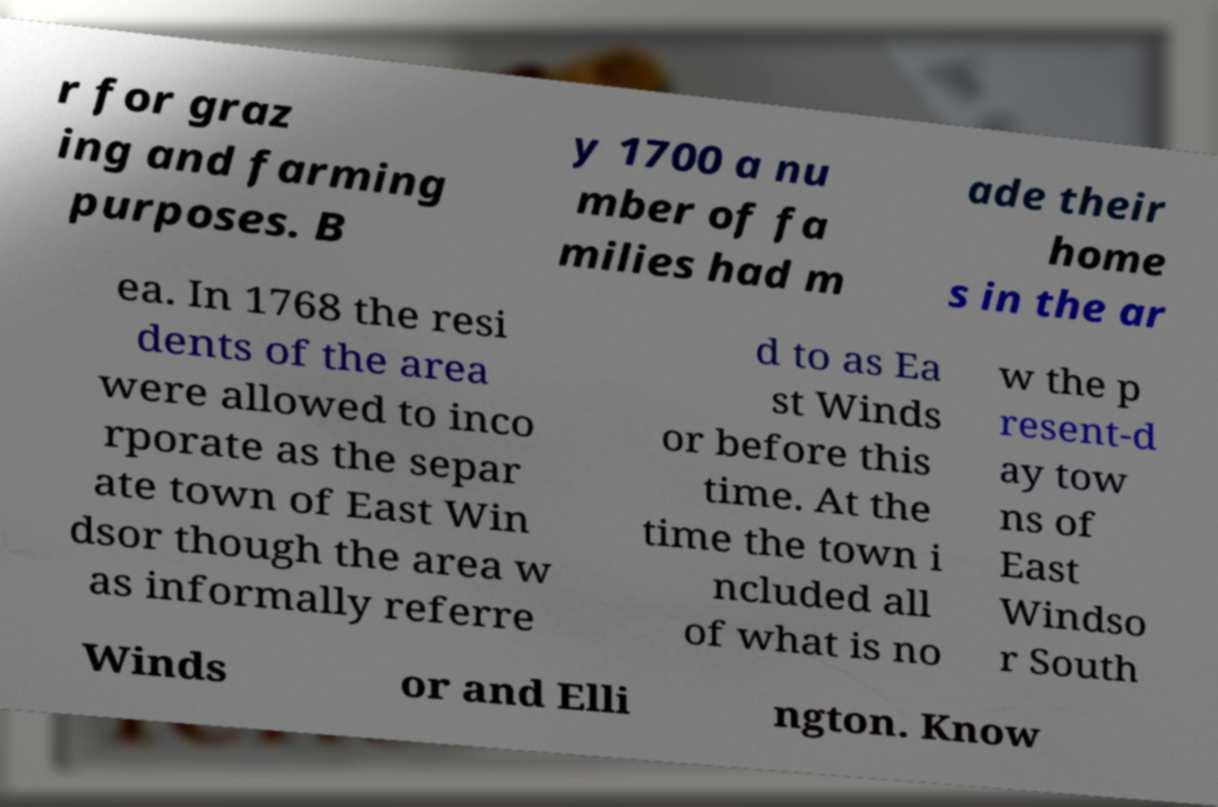Could you assist in decoding the text presented in this image and type it out clearly? r for graz ing and farming purposes. B y 1700 a nu mber of fa milies had m ade their home s in the ar ea. In 1768 the resi dents of the area were allowed to inco rporate as the separ ate town of East Win dsor though the area w as informally referre d to as Ea st Winds or before this time. At the time the town i ncluded all of what is no w the p resent-d ay tow ns of East Windso r South Winds or and Elli ngton. Know 